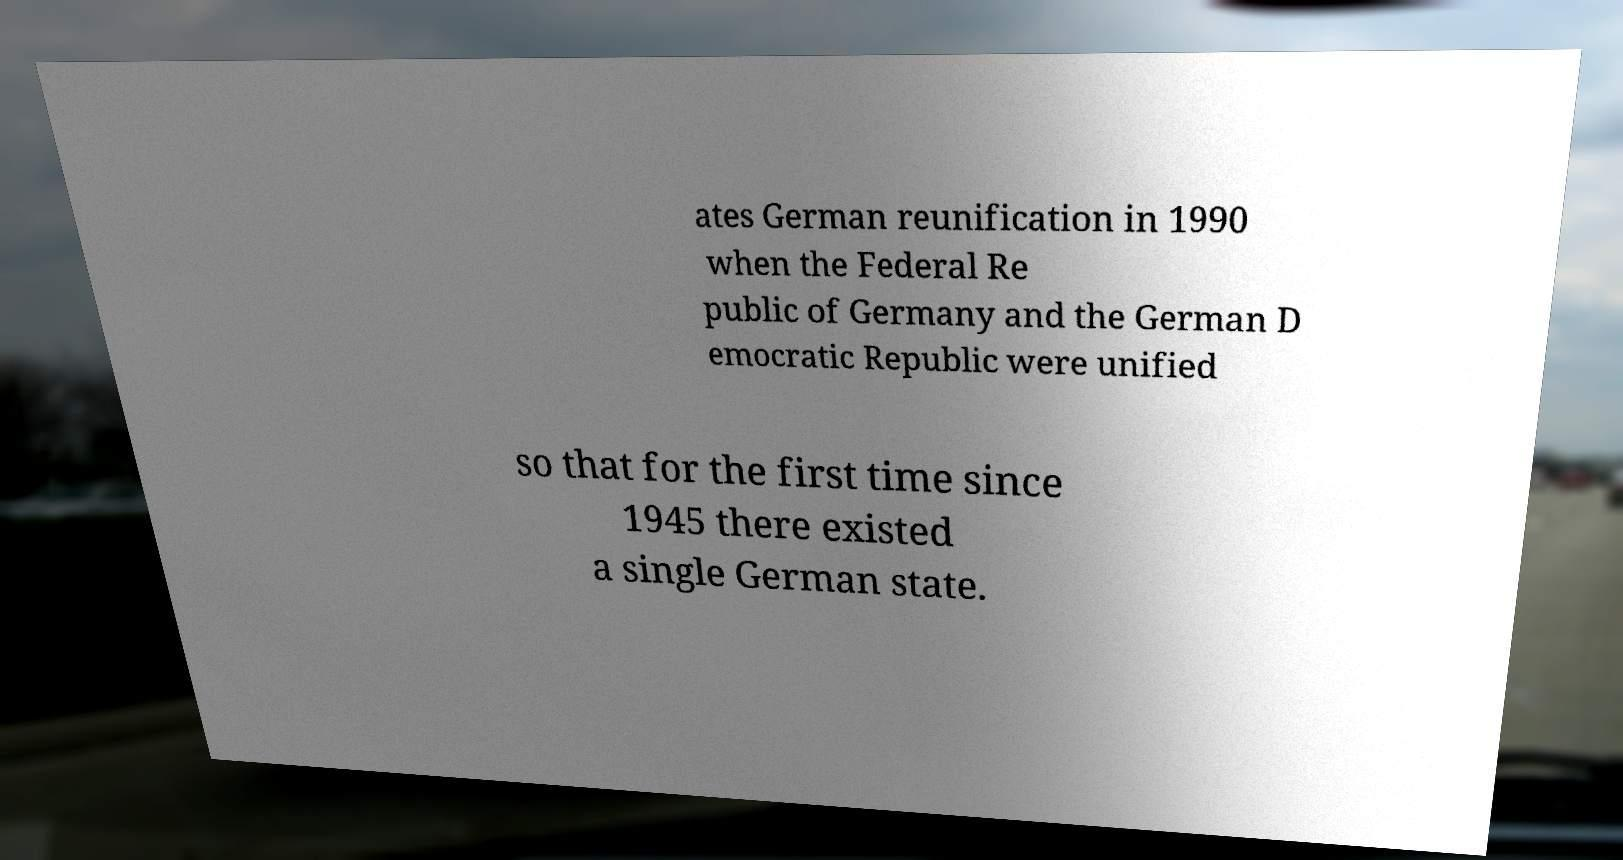Please identify and transcribe the text found in this image. ates German reunification in 1990 when the Federal Re public of Germany and the German D emocratic Republic were unified so that for the first time since 1945 there existed a single German state. 